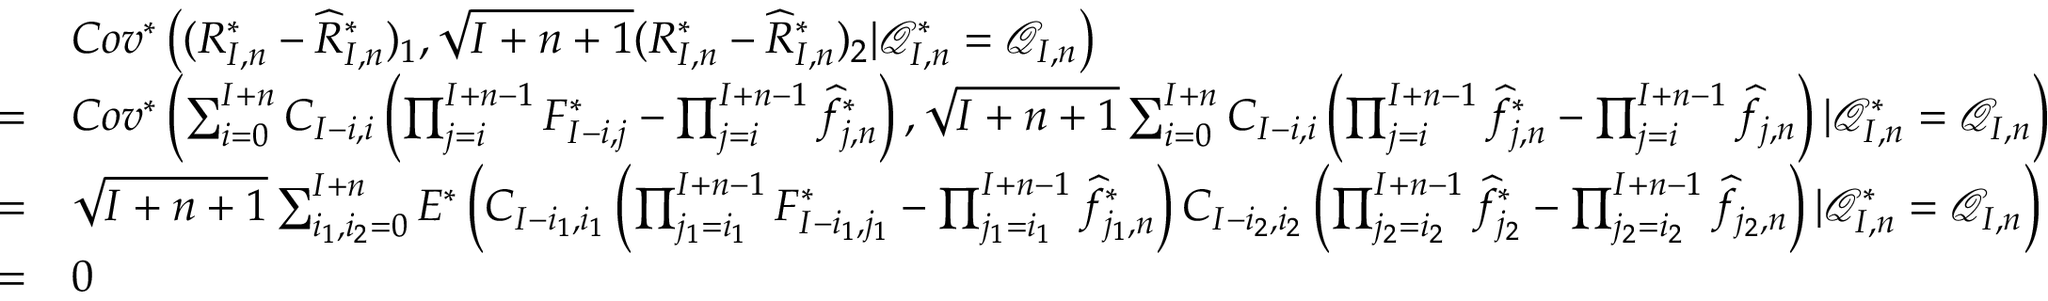Convert formula to latex. <formula><loc_0><loc_0><loc_500><loc_500>\begin{array} { r l } & { C o v ^ { * } \left ( ( R _ { I , n } ^ { * } - \widehat { R } _ { I , n } ^ { * } ) _ { 1 } , \sqrt { I + n + 1 } ( R _ { I , n } ^ { * } - \widehat { R } _ { I , n } ^ { * } ) _ { 2 } | \mathcal { Q } _ { I , n } ^ { * } = \mathcal { Q } _ { I , n } \right ) } \\ { = } & { C o v ^ { * } \left ( \sum _ { i = 0 } ^ { I + n } C _ { I - i , i } \left ( \prod _ { j = i } ^ { I + n - 1 } F _ { I - i , j } ^ { * } - \prod _ { j = i } ^ { I + n - 1 } { \widehat { f } } _ { j , n } ^ { * } \right ) , \sqrt { I + n + 1 } \sum _ { i = 0 } ^ { I + n } C _ { I - i , i } \left ( \prod _ { j = i } ^ { I + n - 1 } { \widehat { f } } _ { j , n } ^ { * } - \prod _ { j = i } ^ { I + n - 1 } \widehat { f } _ { j , n } \right ) | \mathcal { Q } _ { I , n } ^ { * } = \mathcal { Q } _ { I , n } \right ) } \\ { = } & { \sqrt { I + n + 1 } \sum _ { i _ { 1 } , i _ { 2 } = 0 } ^ { I + n } E ^ { * } \left ( C _ { I - i _ { 1 } , i _ { 1 } } \left ( \prod _ { j _ { 1 } = i _ { 1 } } ^ { I + n - 1 } F _ { I - i _ { 1 } , j _ { 1 } } ^ { * } - \prod _ { j _ { 1 } = i _ { 1 } } ^ { I + n - 1 } { \widehat { f } } _ { j _ { 1 } , n } ^ { * } \right ) C _ { I - i _ { 2 } , i _ { 2 } } \left ( \prod _ { j _ { 2 } = i _ { 2 } } ^ { I + n - 1 } { \widehat { f } } _ { j _ { 2 } } ^ { * } - \prod _ { j _ { 2 } = i _ { 2 } } ^ { I + n - 1 } \widehat { f } _ { j _ { 2 } , n } \right ) | \mathcal { Q } _ { I , n } ^ { * } = \mathcal { Q } _ { I , n } \right ) } \\ { = } & { 0 } \end{array}</formula> 